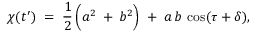Convert formula to latex. <formula><loc_0><loc_0><loc_500><loc_500>\chi ( t ^ { \prime } ) \, = \, \frac { 1 } { 2 } \left ( a ^ { 2 } \, + { } b ^ { 2 } \right ) \, + \, a \, b \, \cos ( \tau + \delta ) ,</formula> 